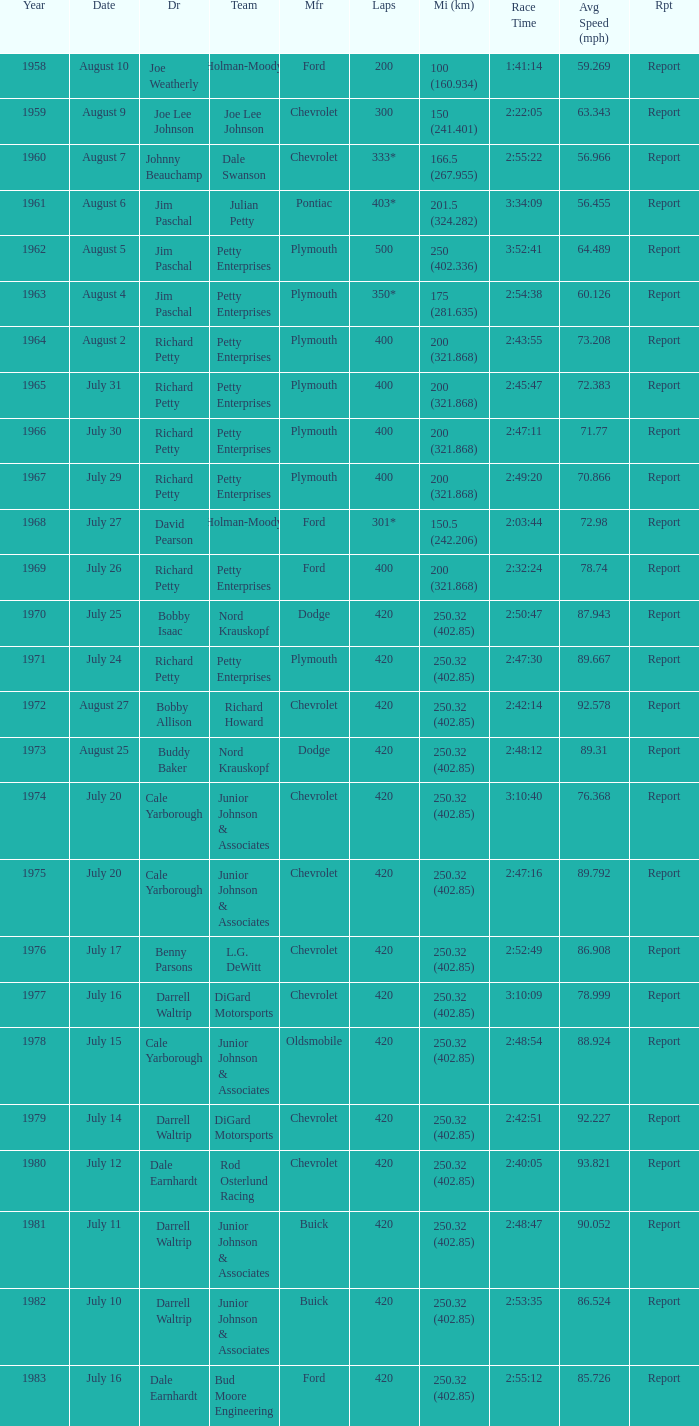How many races did cale yarborough triumph at an average pace of 8 1.0. 